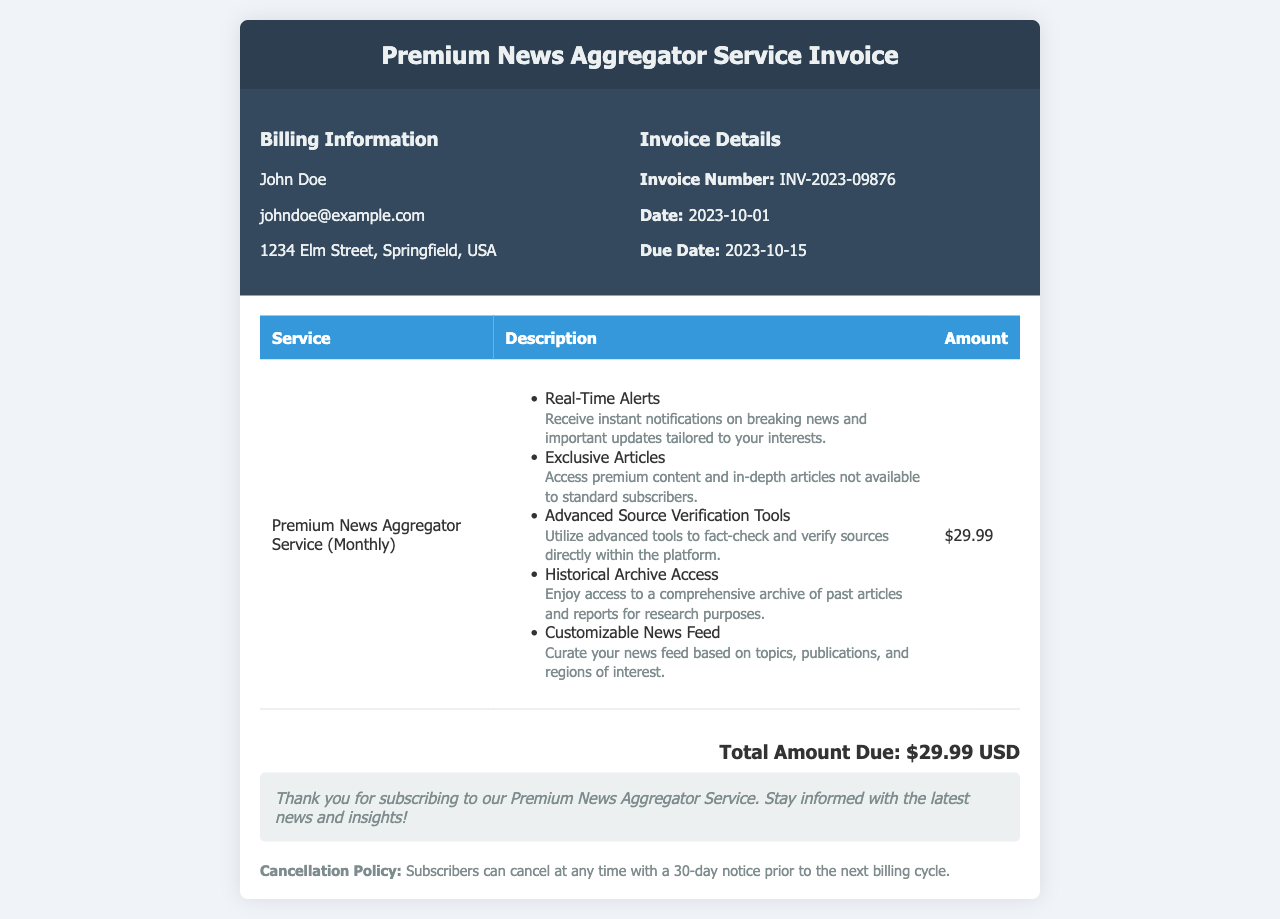What is the invoice number? The invoice number is explicitly stated in the invoice details, which is INV-2023-09876.
Answer: INV-2023-09876 What is the date of the invoice? The date of the invoice is mentioned under the invoice details section, which is 2023-10-01.
Answer: 2023-10-01 What is the total amount due? The total amount due is listed in the total section of the invoice as $29.99 USD.
Answer: $29.99 USD What's included in the Premium News Aggregator Service? Multiple features of the service are described in the main content; they include real-time alerts, exclusive articles, etc.
Answer: Real-Time Alerts, Exclusive Articles, Advanced Source Verification Tools, Historical Archive Access, Customizable News Feed How many days notice must be given to cancel the subscription? The cancellation policy specifies that a 30-day notice is required prior to the next billing cycle.
Answer: 30 days Who is the billed party? The billing information contains the name of the individual who is being billed, which is John Doe.
Answer: John Doe What is the due date for the payment? The due date is provided in the invoice details section, which is 2023-10-15.
Answer: 2023-10-15 What is the name of the service? The service name is mentioned at the beginning of the main content section as Premium News Aggregator Service (Monthly).
Answer: Premium News Aggregator Service (Monthly) 